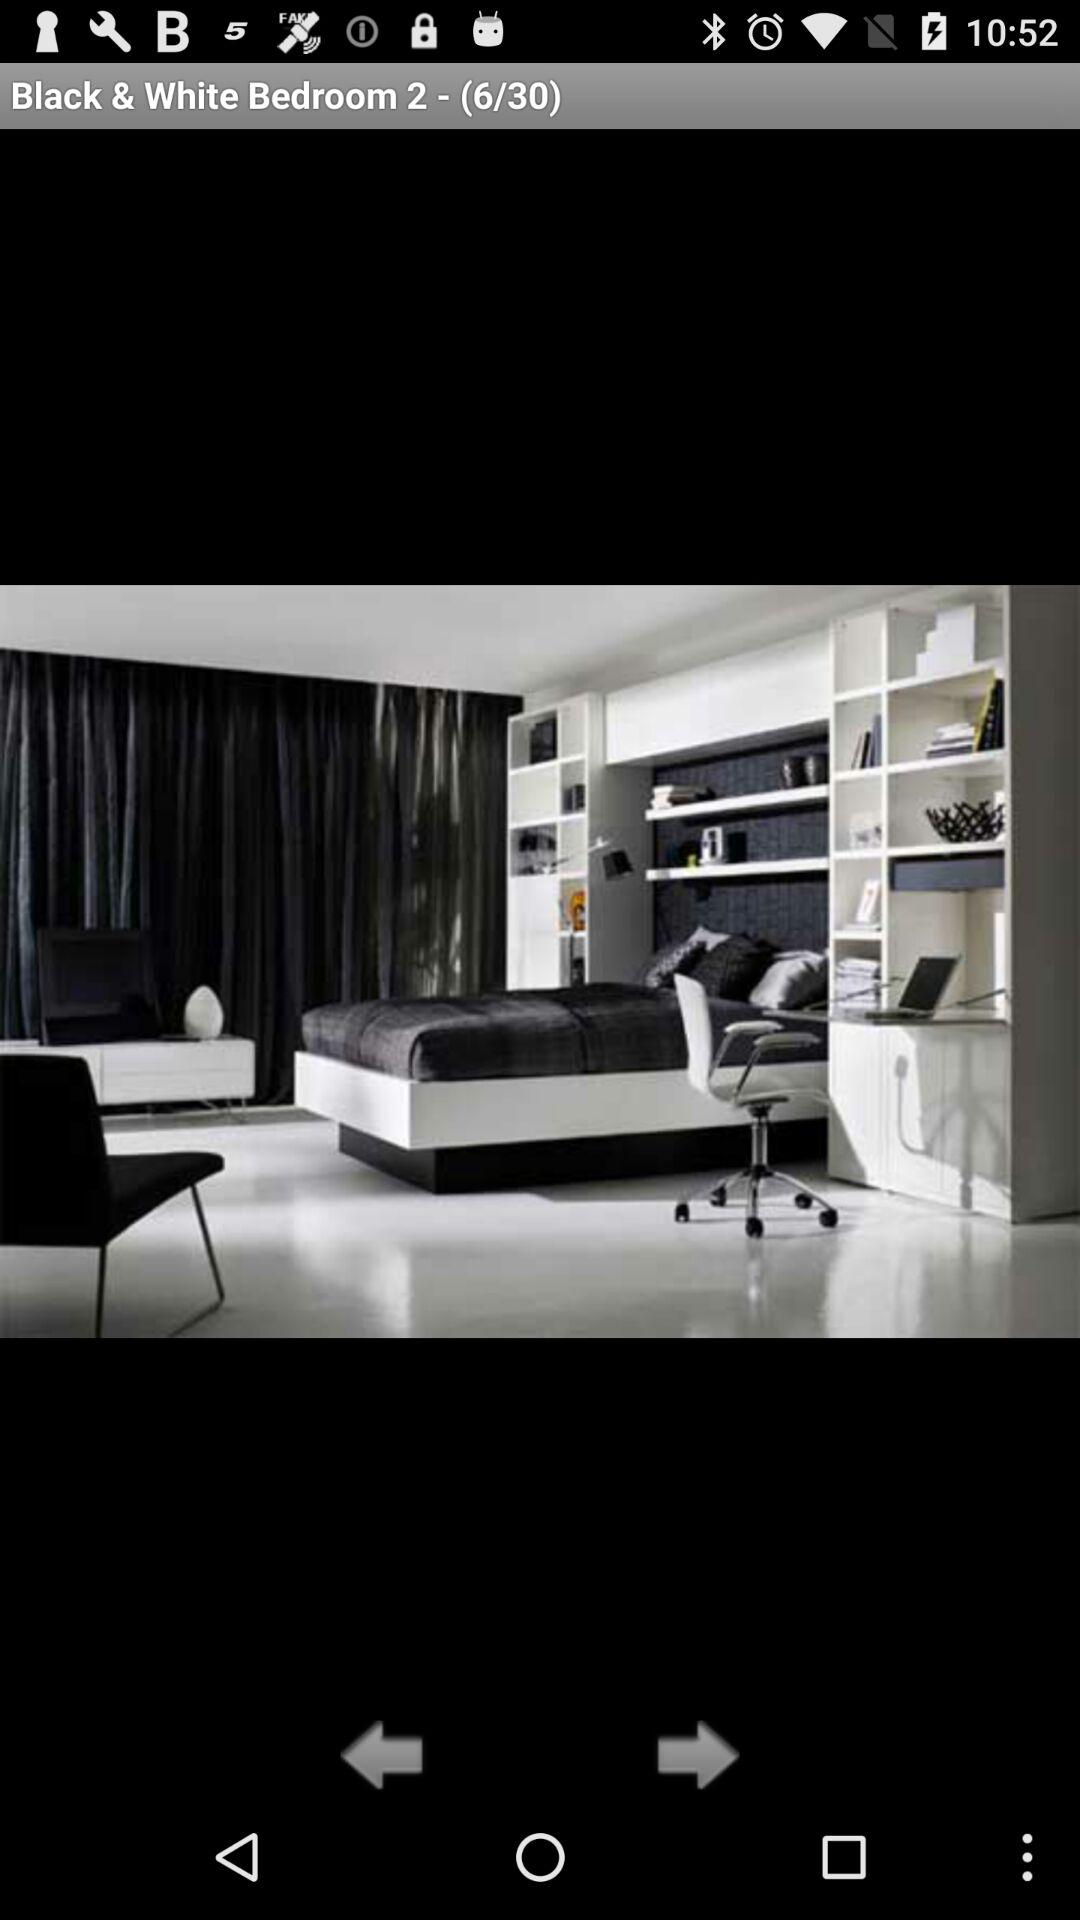How many total Bedroom?
When the provided information is insufficient, respond with <no answer>. <no answer> 